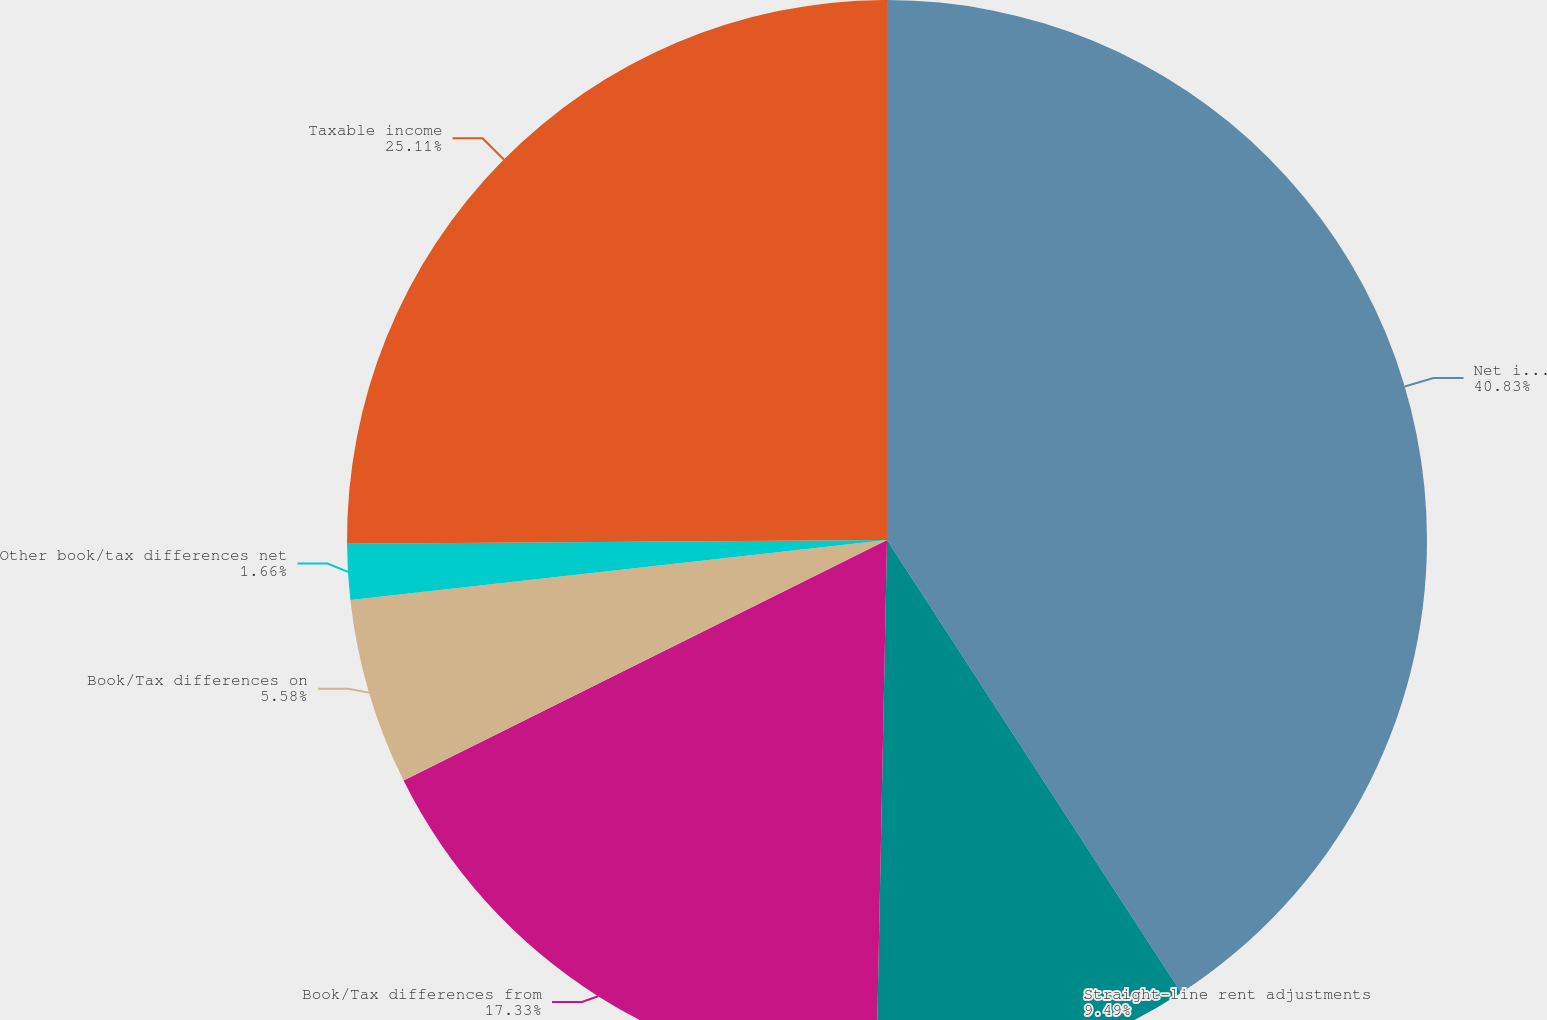Convert chart to OTSL. <chart><loc_0><loc_0><loc_500><loc_500><pie_chart><fcel>Net income available to common<fcel>Straight-line rent adjustments<fcel>Book/Tax differences from<fcel>Book/Tax differences on<fcel>Other book/tax differences net<fcel>Taxable income<nl><fcel>40.83%<fcel>9.49%<fcel>17.33%<fcel>5.58%<fcel>1.66%<fcel>25.11%<nl></chart> 